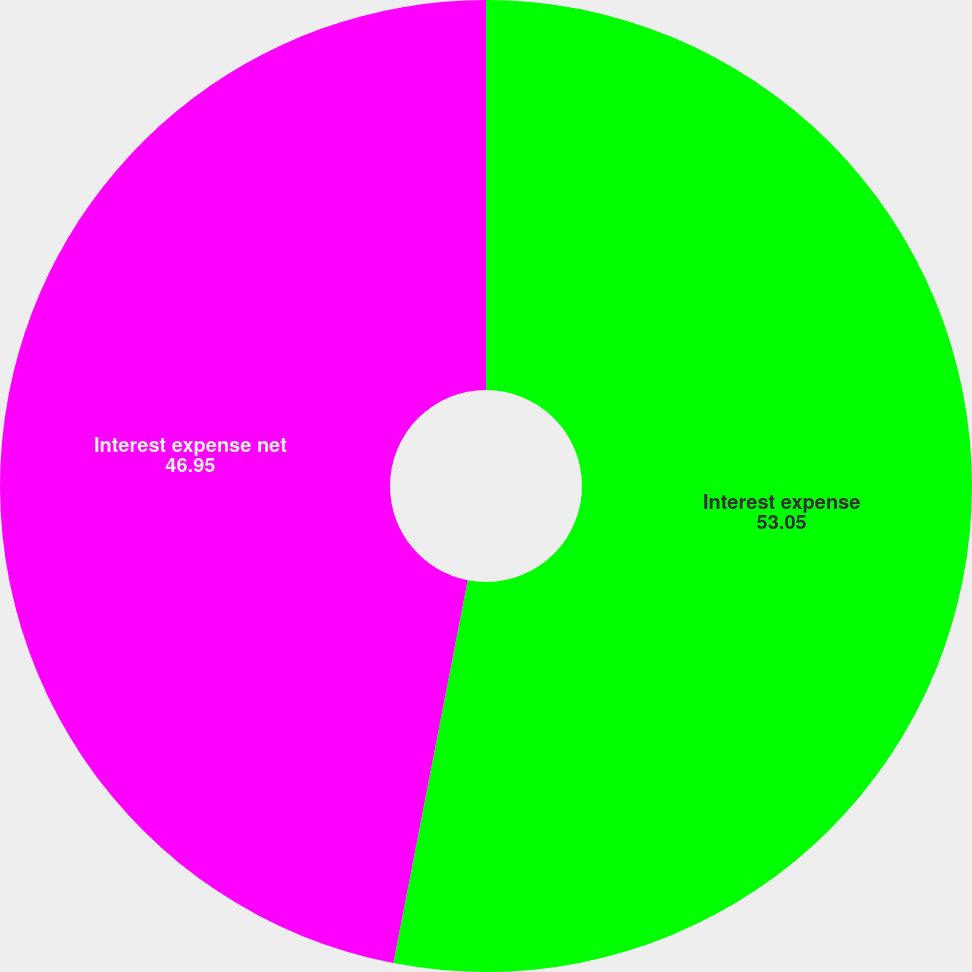<chart> <loc_0><loc_0><loc_500><loc_500><pie_chart><fcel>Interest expense<fcel>Interest expense net<nl><fcel>53.05%<fcel>46.95%<nl></chart> 